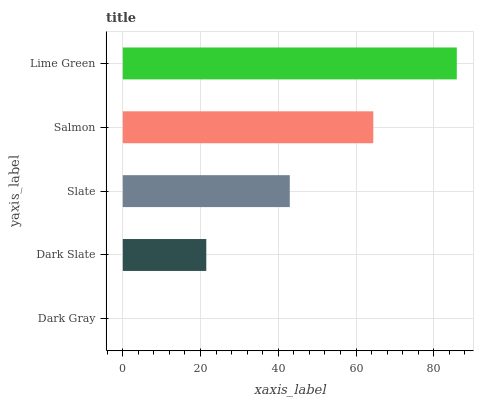Is Dark Gray the minimum?
Answer yes or no. Yes. Is Lime Green the maximum?
Answer yes or no. Yes. Is Dark Slate the minimum?
Answer yes or no. No. Is Dark Slate the maximum?
Answer yes or no. No. Is Dark Slate greater than Dark Gray?
Answer yes or no. Yes. Is Dark Gray less than Dark Slate?
Answer yes or no. Yes. Is Dark Gray greater than Dark Slate?
Answer yes or no. No. Is Dark Slate less than Dark Gray?
Answer yes or no. No. Is Slate the high median?
Answer yes or no. Yes. Is Slate the low median?
Answer yes or no. Yes. Is Dark Slate the high median?
Answer yes or no. No. Is Dark Slate the low median?
Answer yes or no. No. 